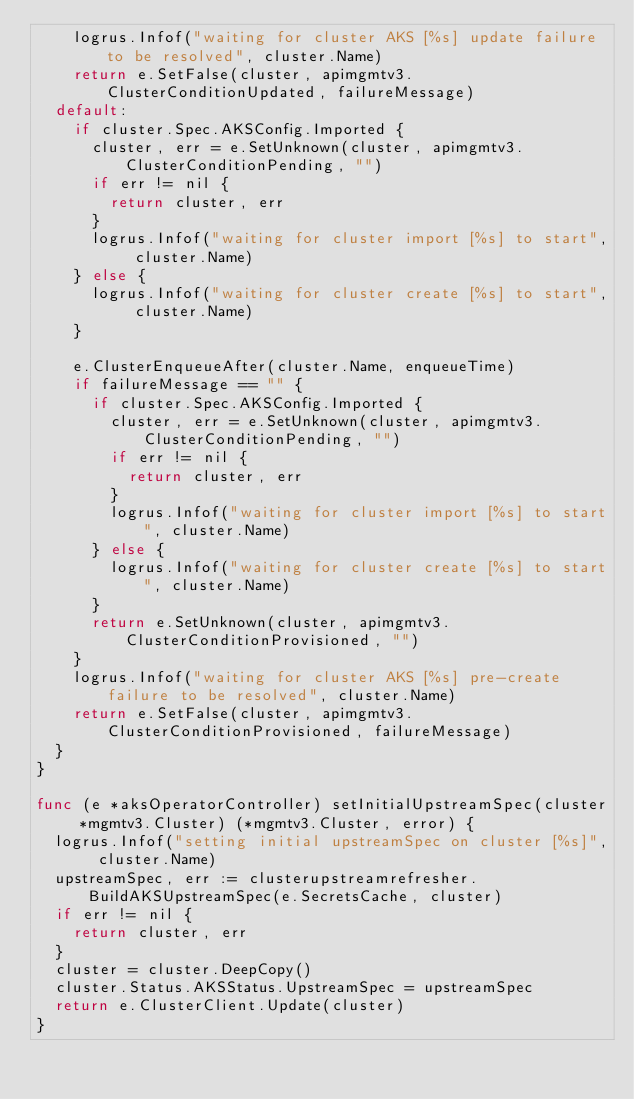Convert code to text. <code><loc_0><loc_0><loc_500><loc_500><_Go_>		logrus.Infof("waiting for cluster AKS [%s] update failure to be resolved", cluster.Name)
		return e.SetFalse(cluster, apimgmtv3.ClusterConditionUpdated, failureMessage)
	default:
		if cluster.Spec.AKSConfig.Imported {
			cluster, err = e.SetUnknown(cluster, apimgmtv3.ClusterConditionPending, "")
			if err != nil {
				return cluster, err
			}
			logrus.Infof("waiting for cluster import [%s] to start", cluster.Name)
		} else {
			logrus.Infof("waiting for cluster create [%s] to start", cluster.Name)
		}

		e.ClusterEnqueueAfter(cluster.Name, enqueueTime)
		if failureMessage == "" {
			if cluster.Spec.AKSConfig.Imported {
				cluster, err = e.SetUnknown(cluster, apimgmtv3.ClusterConditionPending, "")
				if err != nil {
					return cluster, err
				}
				logrus.Infof("waiting for cluster import [%s] to start", cluster.Name)
			} else {
				logrus.Infof("waiting for cluster create [%s] to start", cluster.Name)
			}
			return e.SetUnknown(cluster, apimgmtv3.ClusterConditionProvisioned, "")
		}
		logrus.Infof("waiting for cluster AKS [%s] pre-create failure to be resolved", cluster.Name)
		return e.SetFalse(cluster, apimgmtv3.ClusterConditionProvisioned, failureMessage)
	}
}

func (e *aksOperatorController) setInitialUpstreamSpec(cluster *mgmtv3.Cluster) (*mgmtv3.Cluster, error) {
	logrus.Infof("setting initial upstreamSpec on cluster [%s]", cluster.Name)
	upstreamSpec, err := clusterupstreamrefresher.BuildAKSUpstreamSpec(e.SecretsCache, cluster)
	if err != nil {
		return cluster, err
	}
	cluster = cluster.DeepCopy()
	cluster.Status.AKSStatus.UpstreamSpec = upstreamSpec
	return e.ClusterClient.Update(cluster)
}
</code> 